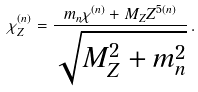Convert formula to latex. <formula><loc_0><loc_0><loc_500><loc_500>\chi ^ { ( n ) } _ { Z } = \frac { m _ { n } \chi ^ { ( n ) } + M _ { Z } Z ^ { 5 ( n ) } } { \sqrt { M _ { Z } ^ { 2 } + m _ { n } ^ { 2 } } } \, .</formula> 